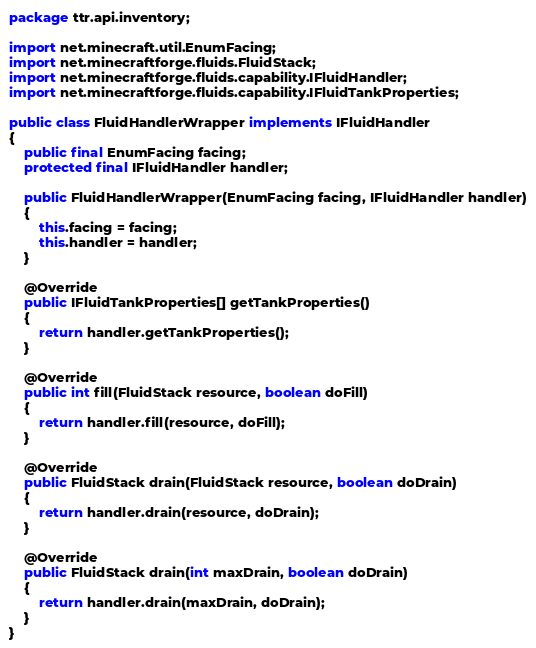<code> <loc_0><loc_0><loc_500><loc_500><_Java_>package ttr.api.inventory;

import net.minecraft.util.EnumFacing;
import net.minecraftforge.fluids.FluidStack;
import net.minecraftforge.fluids.capability.IFluidHandler;
import net.minecraftforge.fluids.capability.IFluidTankProperties;

public class FluidHandlerWrapper implements IFluidHandler
{
	public final EnumFacing facing;
	protected final IFluidHandler handler;

	public FluidHandlerWrapper(EnumFacing facing, IFluidHandler handler)
	{
		this.facing = facing;
		this.handler = handler;
	}
	
	@Override
	public IFluidTankProperties[] getTankProperties()
	{
		return handler.getTankProperties();
	}
	
	@Override
	public int fill(FluidStack resource, boolean doFill)
	{
		return handler.fill(resource, doFill);
	}
	
	@Override
	public FluidStack drain(FluidStack resource, boolean doDrain)
	{
		return handler.drain(resource, doDrain);
	}
	
	@Override
	public FluidStack drain(int maxDrain, boolean doDrain)
	{
		return handler.drain(maxDrain, doDrain);
	}
}</code> 